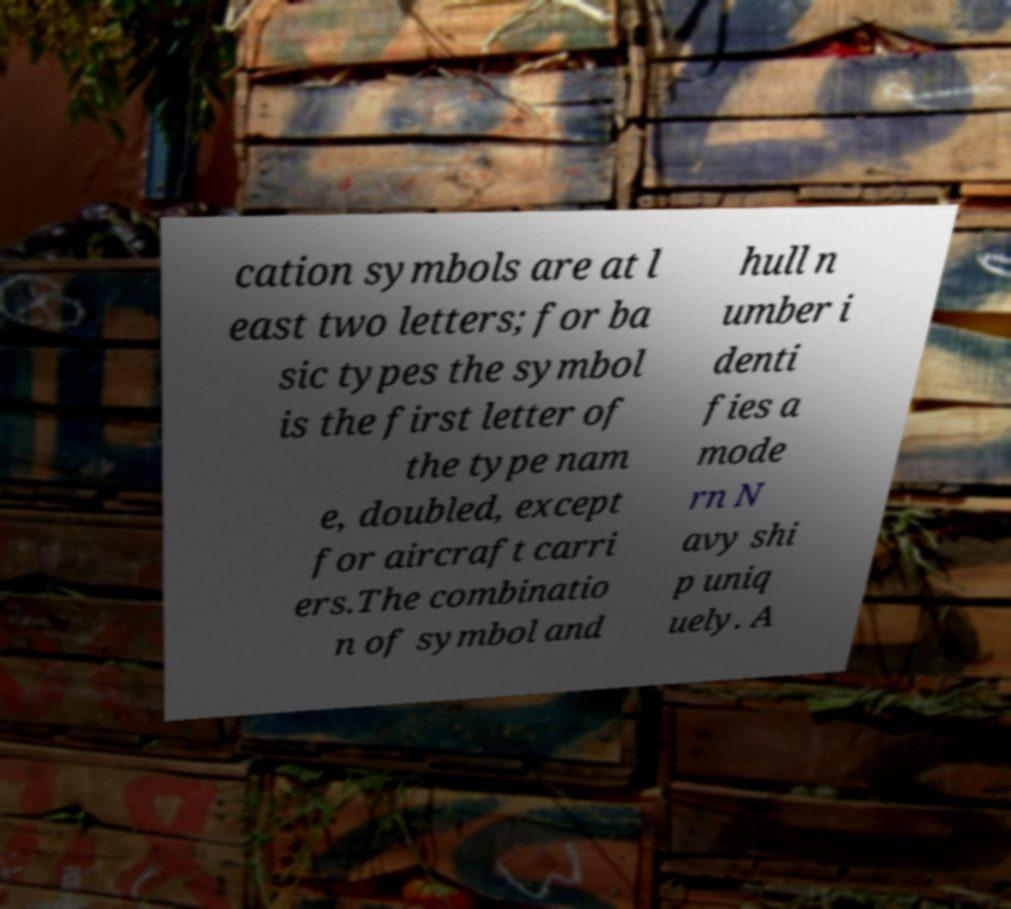Can you accurately transcribe the text from the provided image for me? cation symbols are at l east two letters; for ba sic types the symbol is the first letter of the type nam e, doubled, except for aircraft carri ers.The combinatio n of symbol and hull n umber i denti fies a mode rn N avy shi p uniq uely. A 